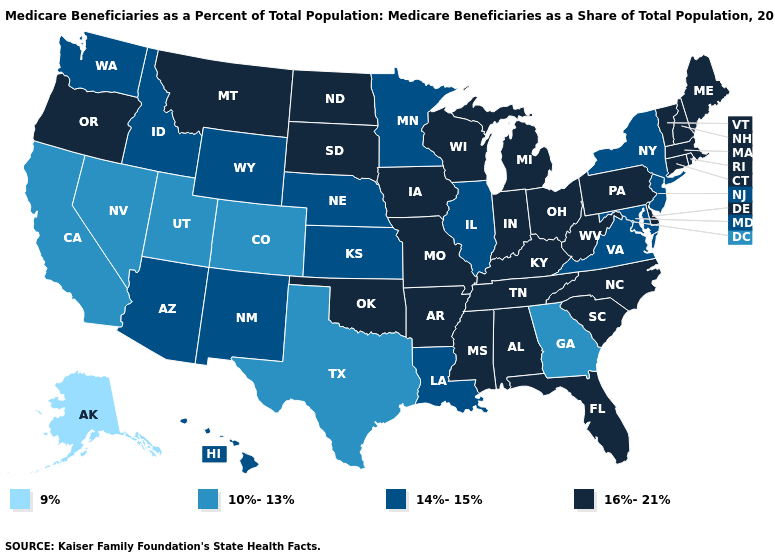What is the lowest value in states that border Maine?
Quick response, please. 16%-21%. Which states have the lowest value in the USA?
Keep it brief. Alaska. Name the states that have a value in the range 10%-13%?
Write a very short answer. California, Colorado, Georgia, Nevada, Texas, Utah. Name the states that have a value in the range 10%-13%?
Give a very brief answer. California, Colorado, Georgia, Nevada, Texas, Utah. How many symbols are there in the legend?
Quick response, please. 4. What is the highest value in the USA?
Give a very brief answer. 16%-21%. What is the value of Nevada?
Give a very brief answer. 10%-13%. What is the value of Arkansas?
Quick response, please. 16%-21%. Is the legend a continuous bar?
Write a very short answer. No. What is the lowest value in states that border Rhode Island?
Concise answer only. 16%-21%. Name the states that have a value in the range 10%-13%?
Keep it brief. California, Colorado, Georgia, Nevada, Texas, Utah. What is the value of North Carolina?
Write a very short answer. 16%-21%. Does the first symbol in the legend represent the smallest category?
Concise answer only. Yes. Among the states that border New Hampshire , which have the highest value?
Keep it brief. Maine, Massachusetts, Vermont. Name the states that have a value in the range 10%-13%?
Quick response, please. California, Colorado, Georgia, Nevada, Texas, Utah. 